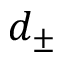<formula> <loc_0><loc_0><loc_500><loc_500>d _ { \pm }</formula> 